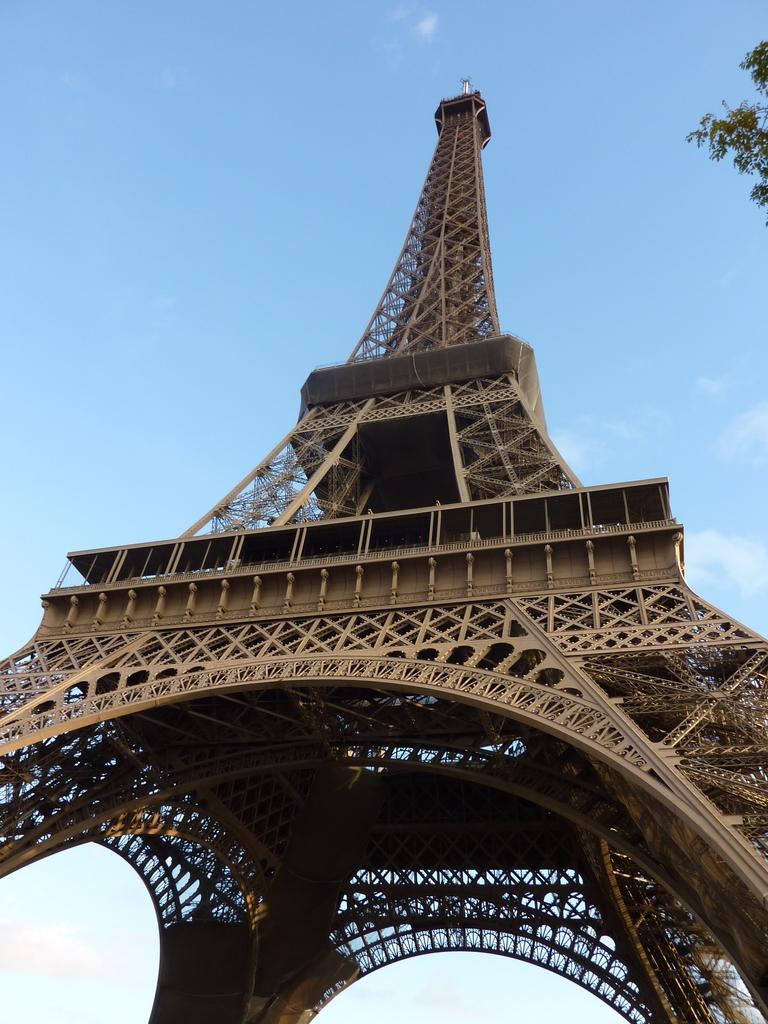What is the main structure visible in the image? There is a tower in the image. What type of vegetation can be seen on the right side of the image? There is a tree visible on the right side of the image. What is visible above the tower and tree in the image? The sky is visible above the tower and tree in the image. Can you see any guitar players performing near the tower in the image? There is no guitar player or any musical performance visible in the image. Are there any tomatoes growing on the tree in the image? There is no indication of tomatoes or any agricultural activity in the image. 